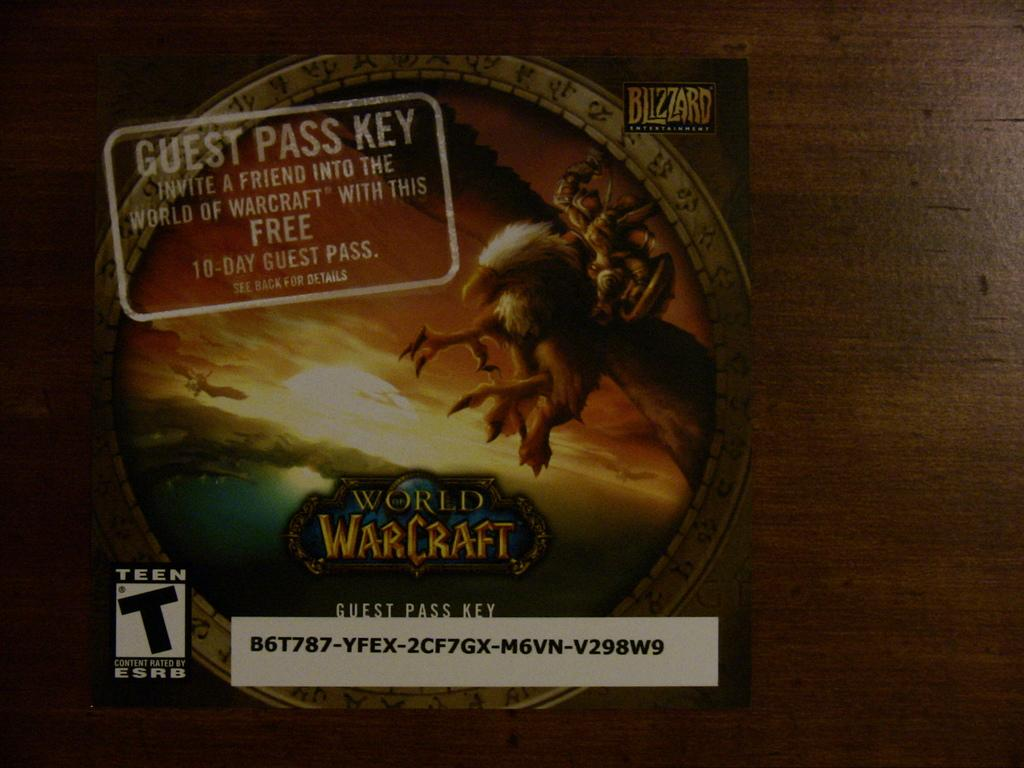<image>
Present a compact description of the photo's key features. A 10-day guest pass key for the world warcraft. 